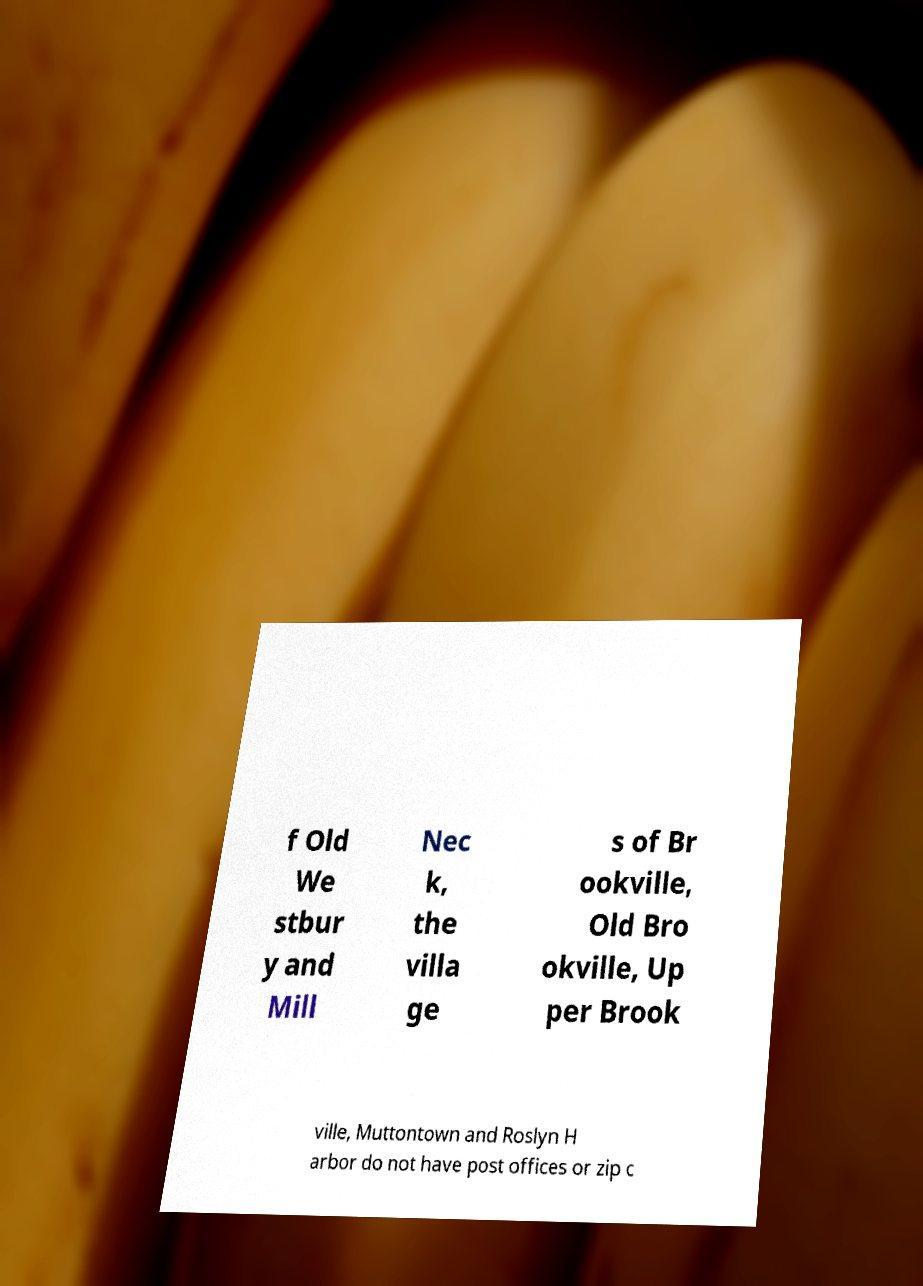Please read and relay the text visible in this image. What does it say? f Old We stbur y and Mill Nec k, the villa ge s of Br ookville, Old Bro okville, Up per Brook ville, Muttontown and Roslyn H arbor do not have post offices or zip c 